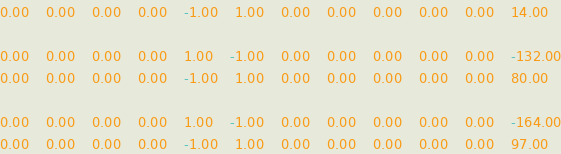<code> <loc_0><loc_0><loc_500><loc_500><_Matlab_>0.00	0.00	0.00	0.00	-1.00	1.00	0.00	0.00	0.00	0.00	0.00	14.00

0.00	0.00	0.00	0.00	1.00	-1.00	0.00	0.00	0.00	0.00	0.00	-132.00
0.00	0.00	0.00	0.00	-1.00	1.00	0.00	0.00	0.00	0.00	0.00	80.00

0.00	0.00	0.00	0.00	1.00	-1.00	0.00	0.00	0.00	0.00	0.00	-164.00
0.00	0.00	0.00	0.00	-1.00	1.00	0.00	0.00	0.00	0.00	0.00	97.00
</code> 